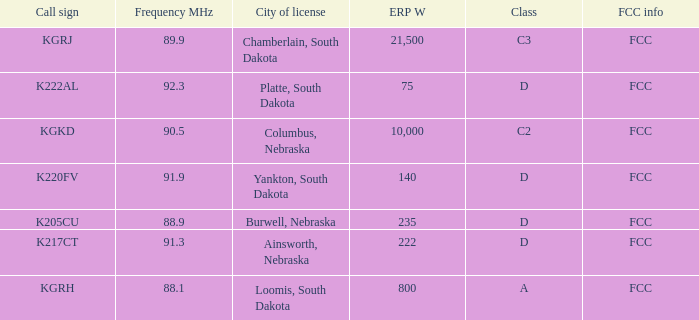What is the total frequency mhz of the kgrj call sign, which has an erp w greater than 21,500? 0.0. Parse the table in full. {'header': ['Call sign', 'Frequency MHz', 'City of license', 'ERP W', 'Class', 'FCC info'], 'rows': [['KGRJ', '89.9', 'Chamberlain, South Dakota', '21,500', 'C3', 'FCC'], ['K222AL', '92.3', 'Platte, South Dakota', '75', 'D', 'FCC'], ['KGKD', '90.5', 'Columbus, Nebraska', '10,000', 'C2', 'FCC'], ['K220FV', '91.9', 'Yankton, South Dakota', '140', 'D', 'FCC'], ['K205CU', '88.9', 'Burwell, Nebraska', '235', 'D', 'FCC'], ['K217CT', '91.3', 'Ainsworth, Nebraska', '222', 'D', 'FCC'], ['KGRH', '88.1', 'Loomis, South Dakota', '800', 'A', 'FCC']]} 